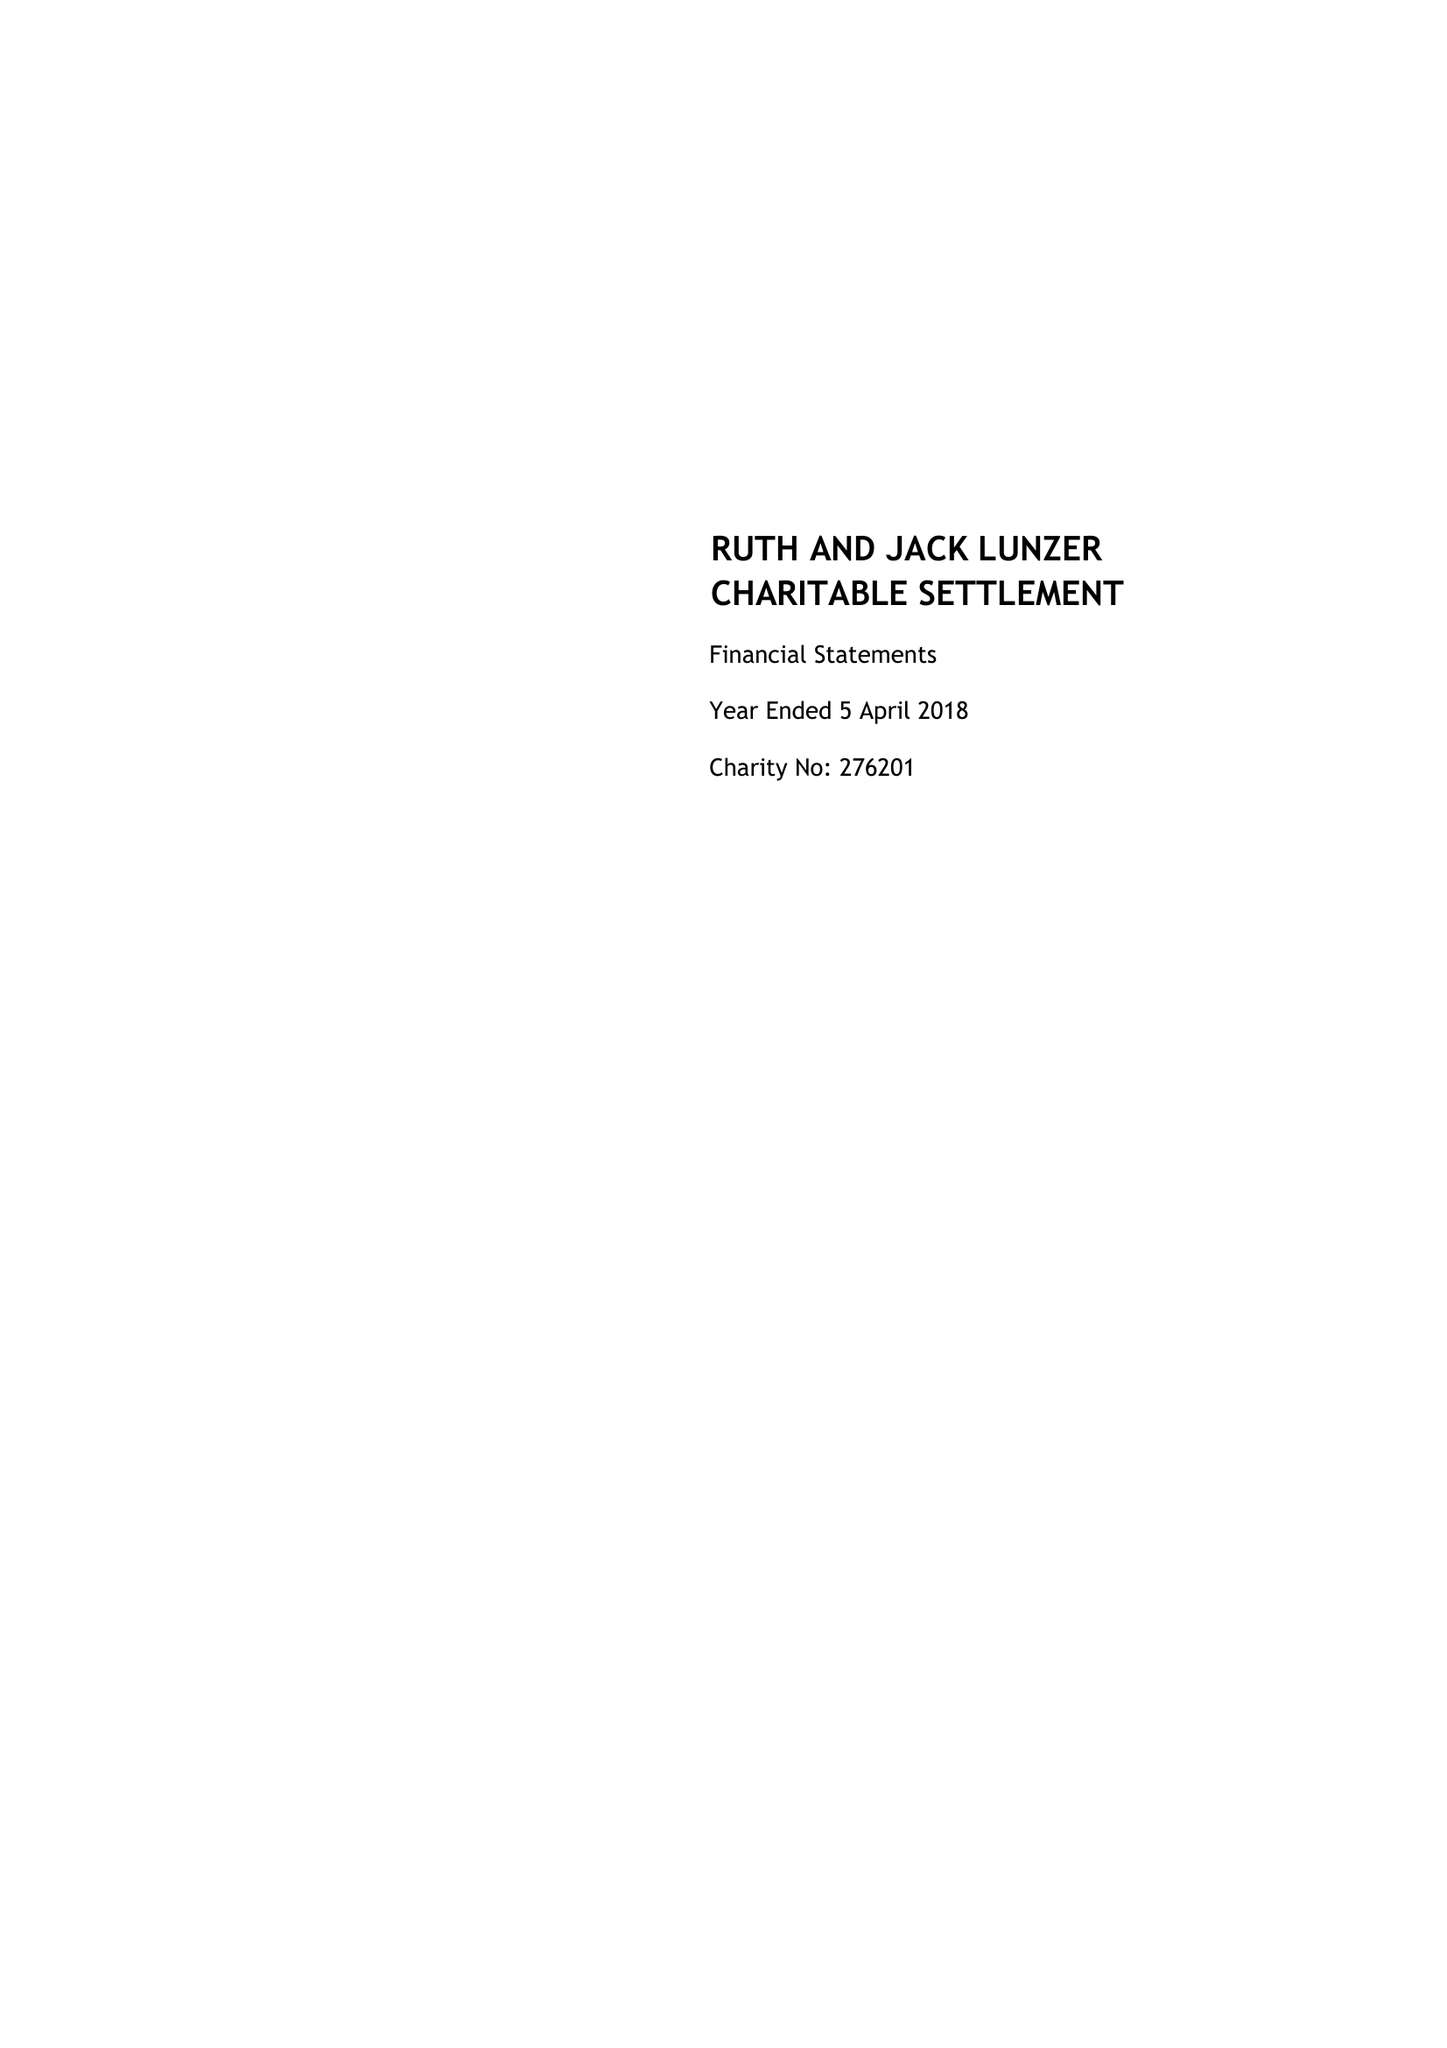What is the value for the spending_annually_in_british_pounds?
Answer the question using a single word or phrase. 9582.00 